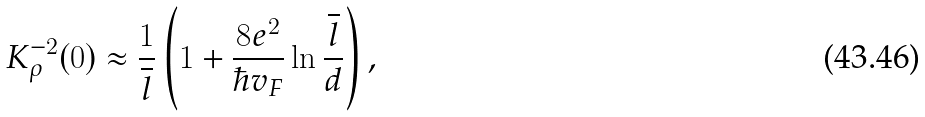Convert formula to latex. <formula><loc_0><loc_0><loc_500><loc_500>K _ { \rho } ^ { - 2 } ( 0 ) \approx \frac { 1 } { \overline { l } } \left ( 1 + \frac { 8 e ^ { 2 } } { \hbar { v } _ { F } } \ln \frac { \overline { l } } { d } \right ) ,</formula> 